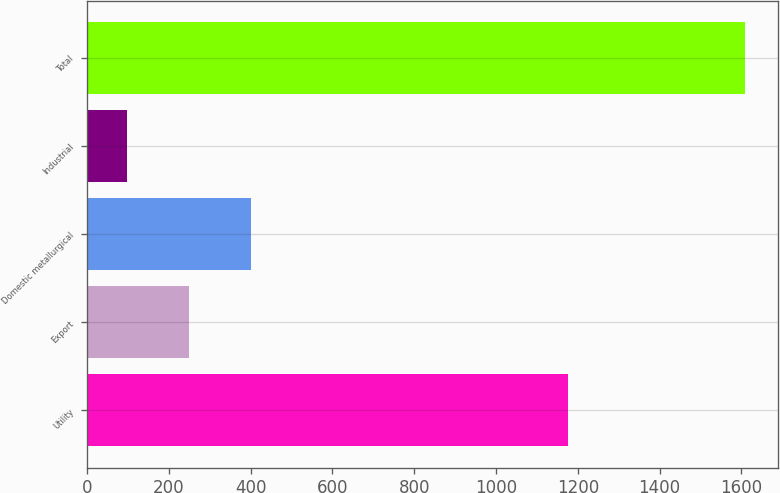<chart> <loc_0><loc_0><loc_500><loc_500><bar_chart><fcel>Utility<fcel>Export<fcel>Domestic metallurgical<fcel>Industrial<fcel>Total<nl><fcel>1175<fcel>248.89<fcel>400.08<fcel>97.7<fcel>1609.6<nl></chart> 